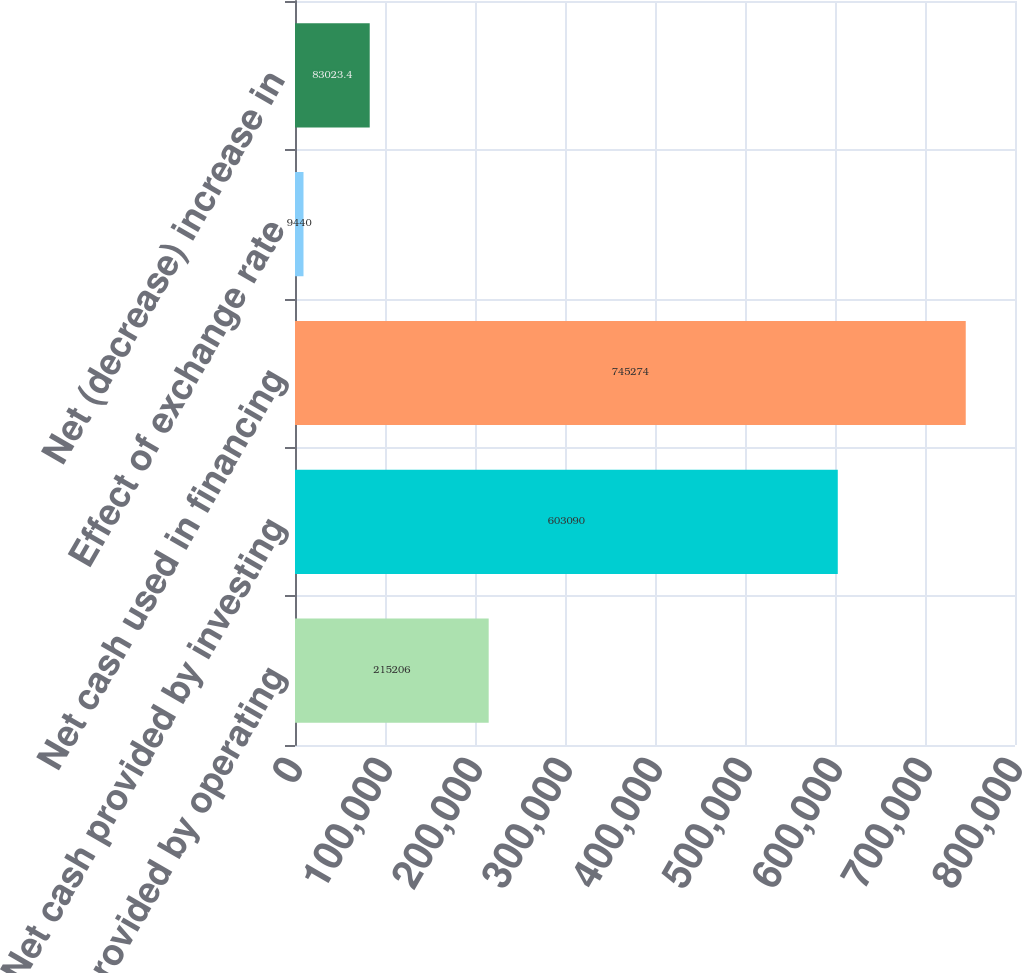<chart> <loc_0><loc_0><loc_500><loc_500><bar_chart><fcel>Net cash provided by operating<fcel>Net cash provided by investing<fcel>Net cash used in financing<fcel>Effect of exchange rate<fcel>Net (decrease) increase in<nl><fcel>215206<fcel>603090<fcel>745274<fcel>9440<fcel>83023.4<nl></chart> 